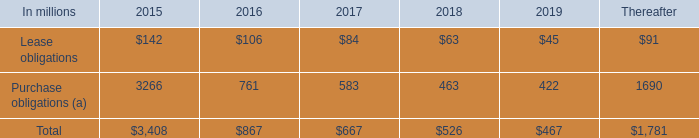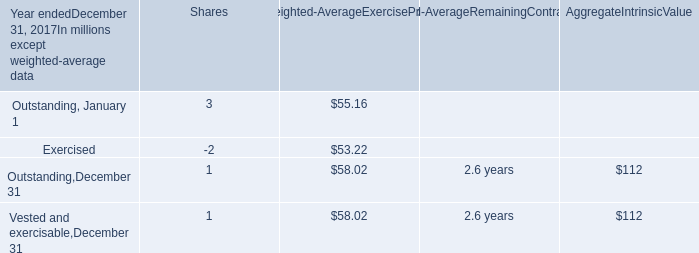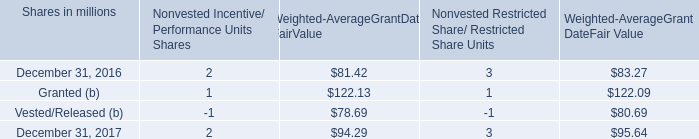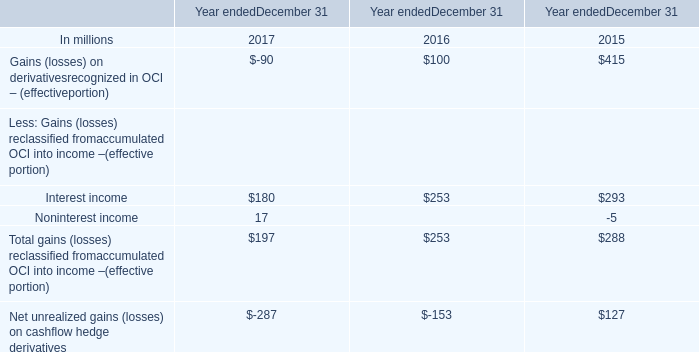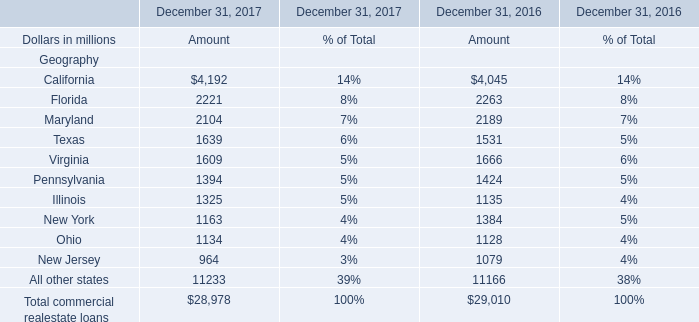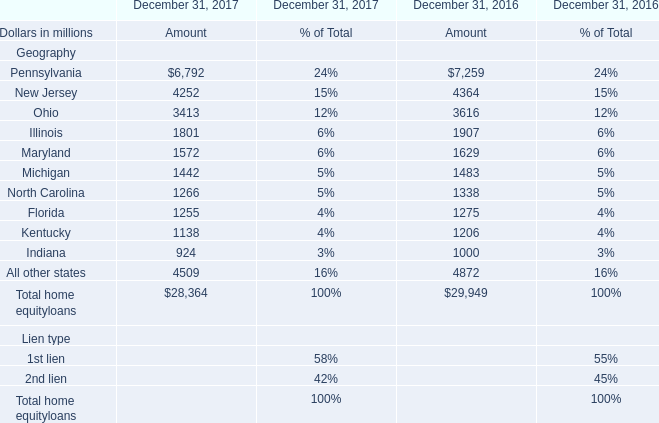What is the growing rate of Texas in the year with the most Illinois? 
Computations: ((1639 - 1531) / 1531)
Answer: 0.07054. 